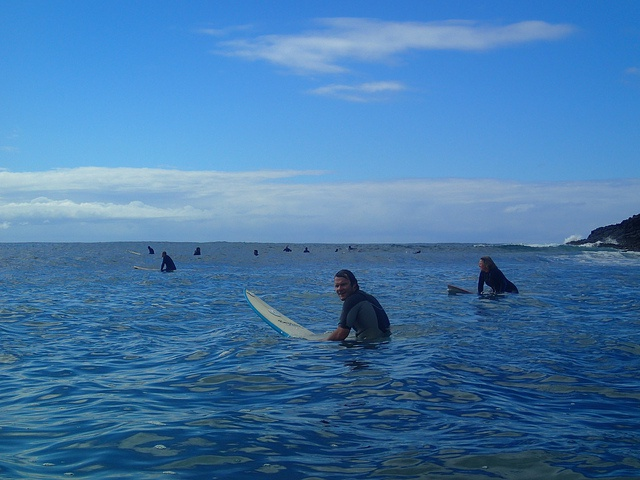Describe the objects in this image and their specific colors. I can see people in gray, black, navy, and blue tones, surfboard in gray, darkgray, and blue tones, people in gray, black, navy, darkblue, and blue tones, people in gray, navy, and blue tones, and surfboard in gray and blue tones in this image. 